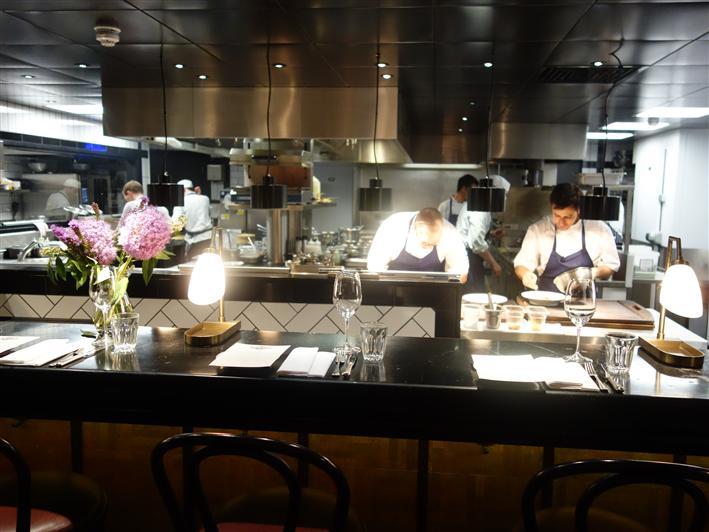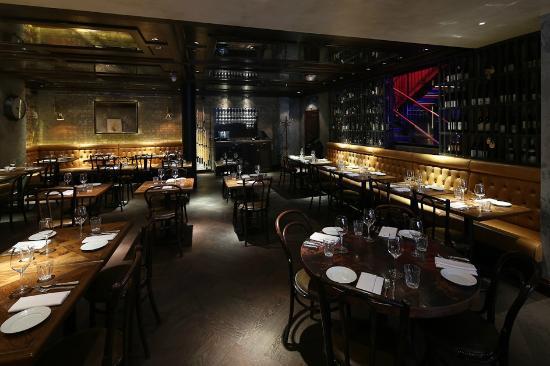The first image is the image on the left, the second image is the image on the right. For the images shown, is this caption "Each image shows an empty restaurant with no people visible." true? Answer yes or no. No. The first image is the image on the left, the second image is the image on the right. Examine the images to the left and right. Is the description "An interior of a restaurant has yellow tufted bench seating around its perimeter and has a view of a staircase glowing violet and blue above the seating on the right." accurate? Answer yes or no. Yes. 